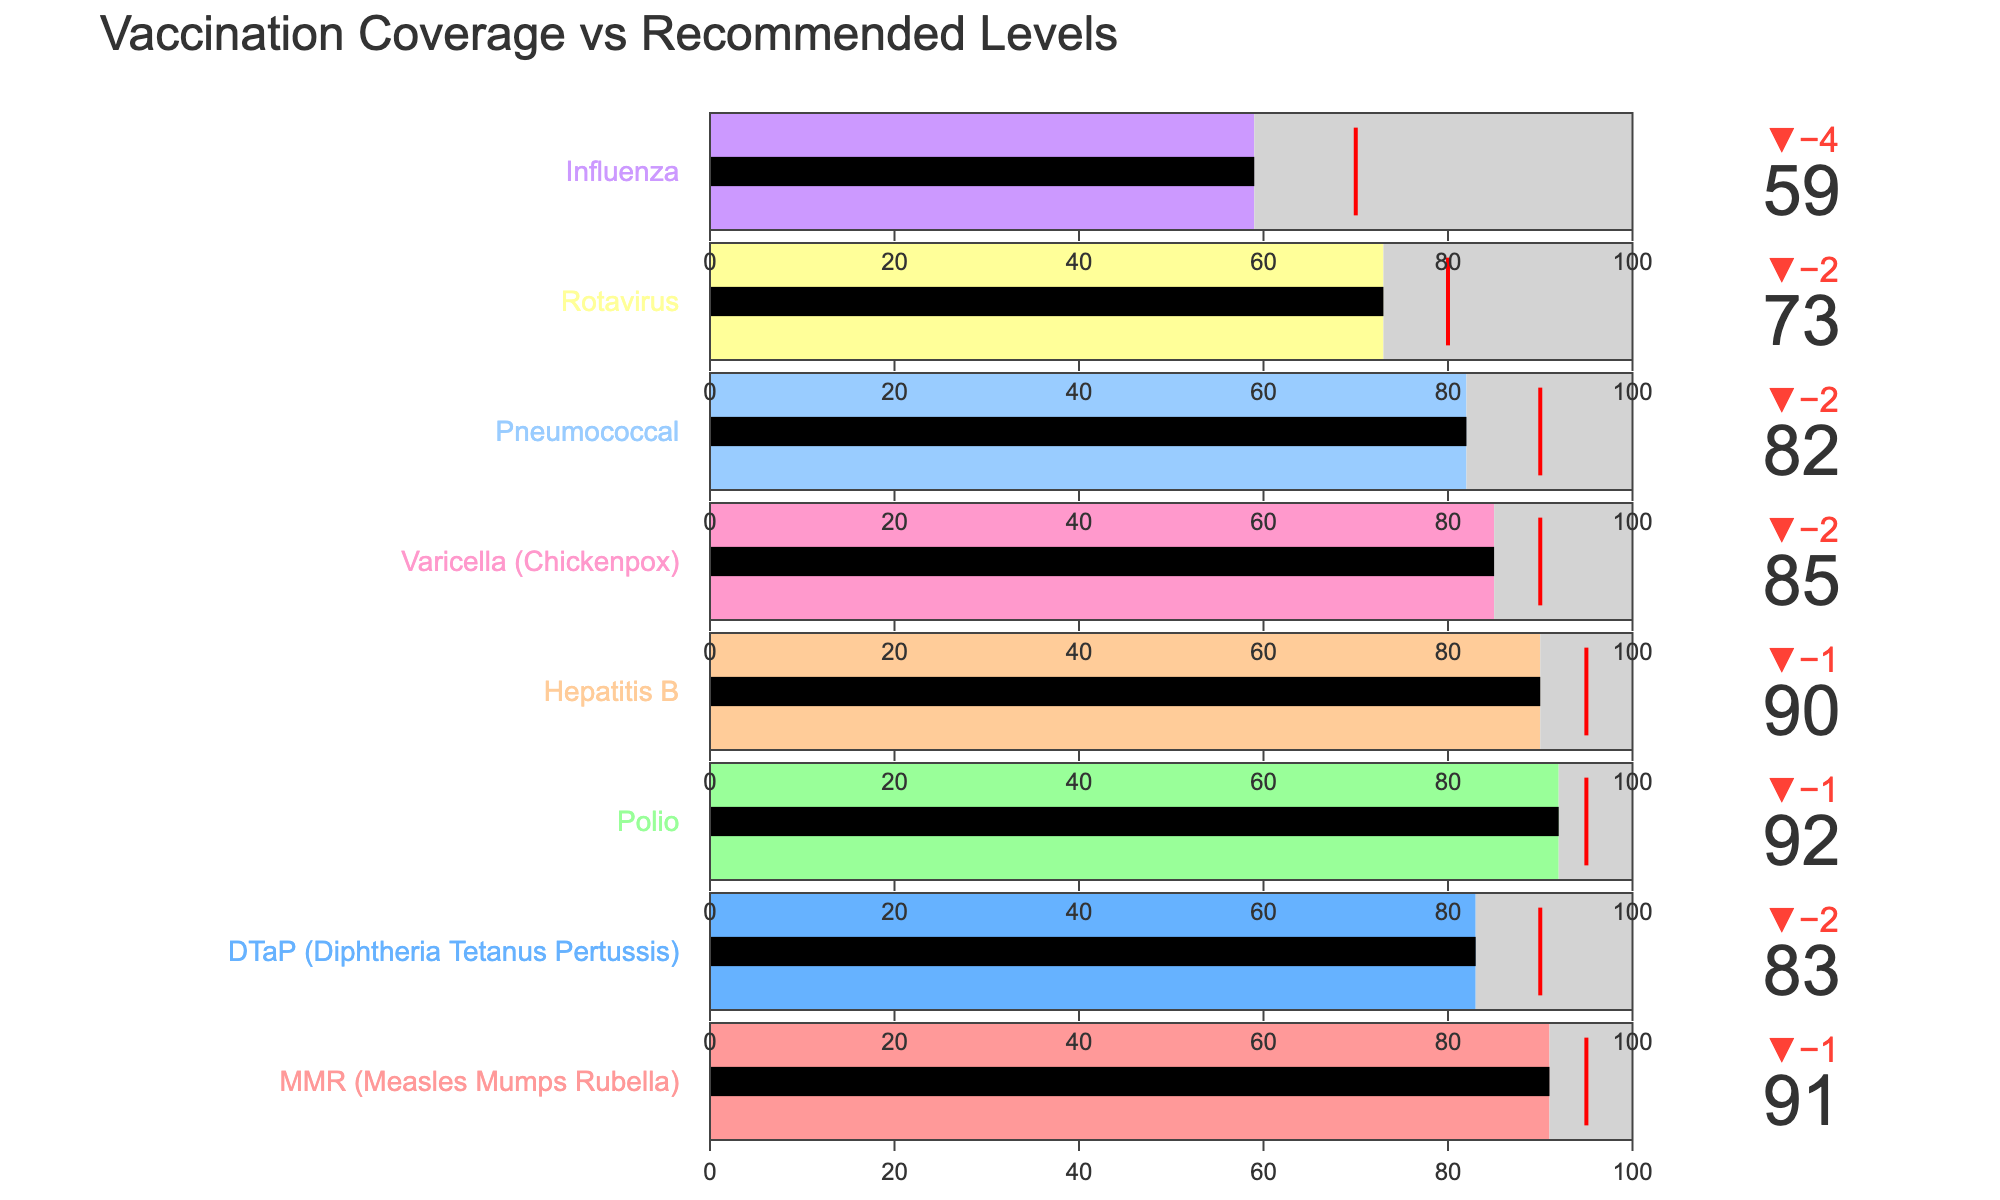What's the title of the figure? The title is displayed prominently at the top of the figure, indicating the main subject of the graph.
Answer: Vaccination Coverage vs Recommended Levels How many vaccines are shown in the figure? Count the number of distinct vaccine names listed at the side of the bullet charts.
Answer: 8 Which vaccine has the lowest actual coverage percentage? Look for the bullet chart with the smallest value on the actual coverage bar.
Answer: Influenza What is the actual coverage percentage for DTaP (Diphtheria Tetanus Pertussis)? Identify the bullet chart titled "DTaP (Diphtheria Tetanus Pertussis)" and read the value on the coverage bar.
Answer: 83 How does the actual coverage for Varicella compare to its recommended coverage? Compare the value of the actual coverage bar to the recommended coverage threshold for the Varicella vaccine.
Answer: Varicella actual coverage (85) is below its recommended coverage (90) Which vaccine's actual coverage exceeds the national average? Identify the bullet charts where the actual coverage bar is higher than the national average shown as a marker.
Answer: Polio What is the average actual coverage percentage for all vaccines combined? Sum all the actual coverage values and divide by the number of vaccines (8).
Answer: (91 + 83 + 92 + 90 + 85 + 82 + 73 + 59) / 8 = 82.125 Which vaccines have an actual coverage greater than 90%? Identify the bullet charts where the actual coverage value is greater than 90.
Answer: MMR, Polio What is the difference between the actual and recommended coverage for Hepatitis B? Subtract the actual coverage value from the recommended coverage value for Hepatitis B.
Answer: 95 - 90 = 5 How many vaccines have an actual coverage percentage less than 80%? Count the bullet charts where the actual coverage bar shows a value below 80.
Answer: 2 (Rotavirus, Influenza) 